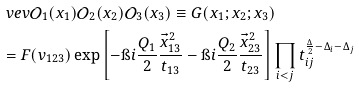Convert formula to latex. <formula><loc_0><loc_0><loc_500><loc_500>& \ v e v { \mathcal { O } _ { 1 } ( x _ { 1 } ) \mathcal { O } _ { 2 } ( x _ { 2 } ) \mathcal { O } _ { 3 } ( x _ { 3 } ) } \equiv G ( x _ { 1 } ; x _ { 2 } ; x _ { 3 } ) \\ & = F ( v _ { 1 2 3 } ) \exp \left [ - \i i \frac { Q _ { 1 } } { 2 } \frac { \vec { x } _ { 1 3 } ^ { 2 } } { t _ { 1 3 } } - \i i \frac { Q _ { 2 } } { 2 } \frac { \vec { x } _ { 2 3 } ^ { 2 } } { t _ { 2 3 } } \right ] \prod _ { i < j } t _ { i j } ^ { \frac { \Delta } { 2 } - \Delta _ { i } - \Delta _ { j } }</formula> 